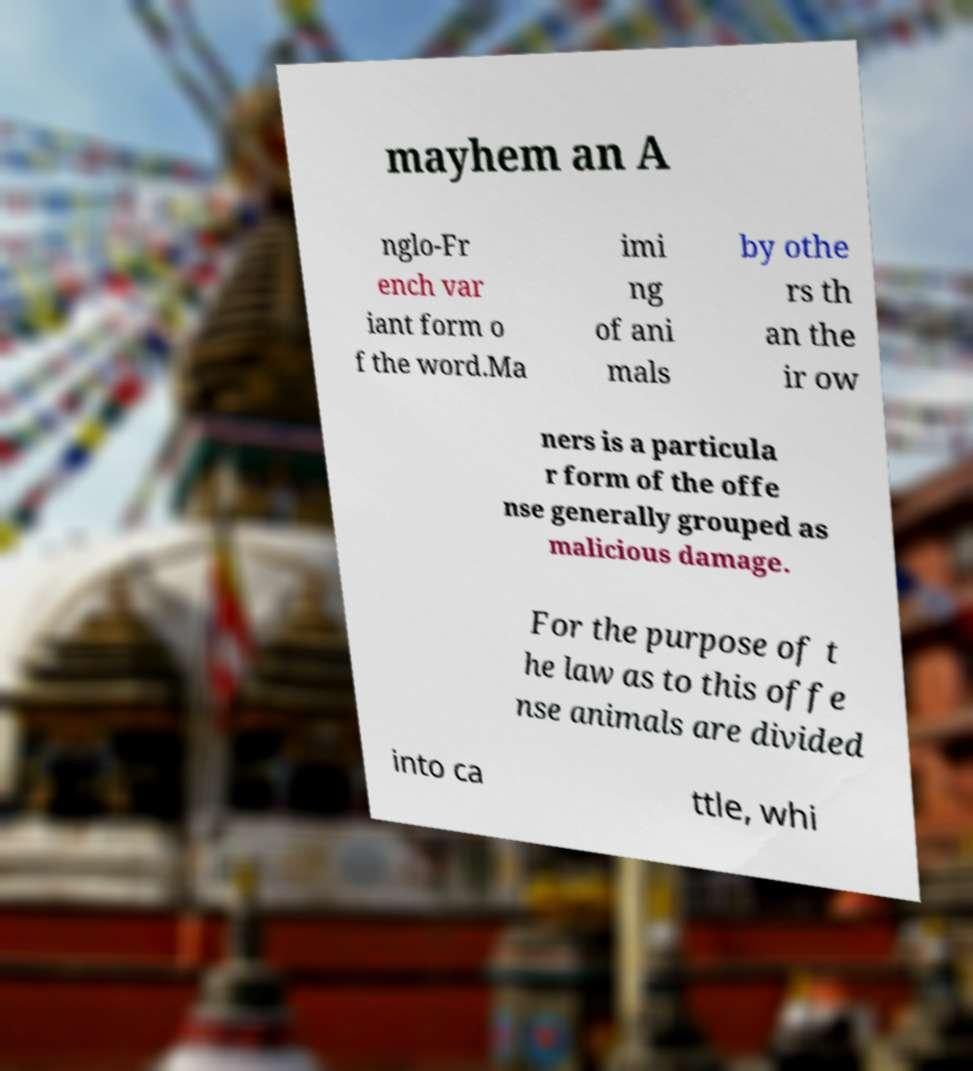Can you read and provide the text displayed in the image?This photo seems to have some interesting text. Can you extract and type it out for me? mayhem an A nglo-Fr ench var iant form o f the word.Ma imi ng of ani mals by othe rs th an the ir ow ners is a particula r form of the offe nse generally grouped as malicious damage. For the purpose of t he law as to this offe nse animals are divided into ca ttle, whi 